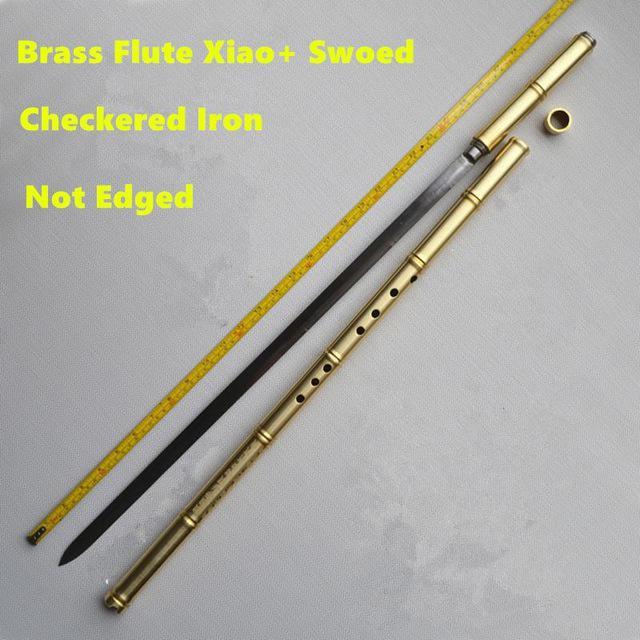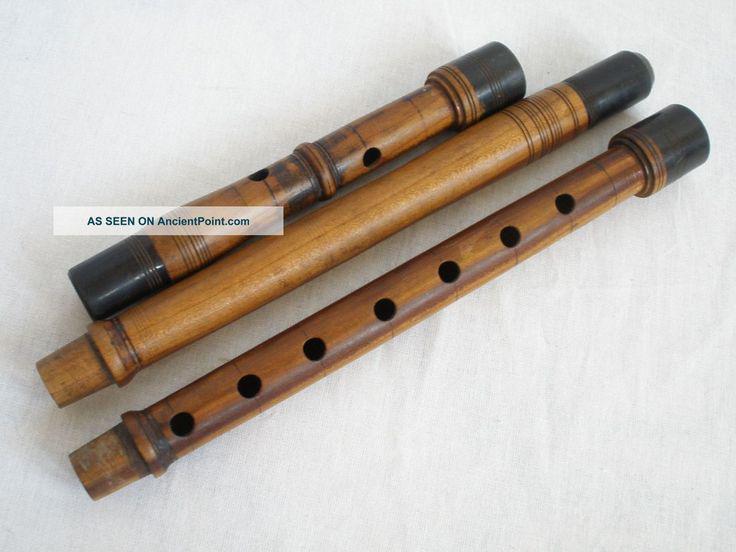The first image is the image on the left, the second image is the image on the right. Evaluate the accuracy of this statement regarding the images: "There are two instruments.". Is it true? Answer yes or no. No. The first image is the image on the left, the second image is the image on the right. Examine the images to the left and right. Is the description "There are exactly two flutes." accurate? Answer yes or no. No. 